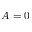<formula> <loc_0><loc_0><loc_500><loc_500>A = 0</formula> 